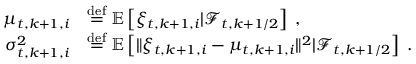<formula> <loc_0><loc_0><loc_500><loc_500>\begin{array} { r l } { \mu _ { t , k + 1 , i } } & { { \stackrel { d e f } { = } } \mathbb { E } \left [ \xi _ { t , k + 1 , i } | \mathcal { F } _ { t , k + 1 / 2 } \right ] \, , } \\ { \sigma _ { t , k + 1 , i } ^ { 2 } } & { { \stackrel { d e f } { = } } \mathbb { E } \left [ \| \xi _ { t , k + 1 , i } - \mu _ { t , k + 1 , i } \| ^ { 2 } | \mathcal { F } _ { t , k + 1 / 2 } \right ] \, . } \end{array}</formula> 